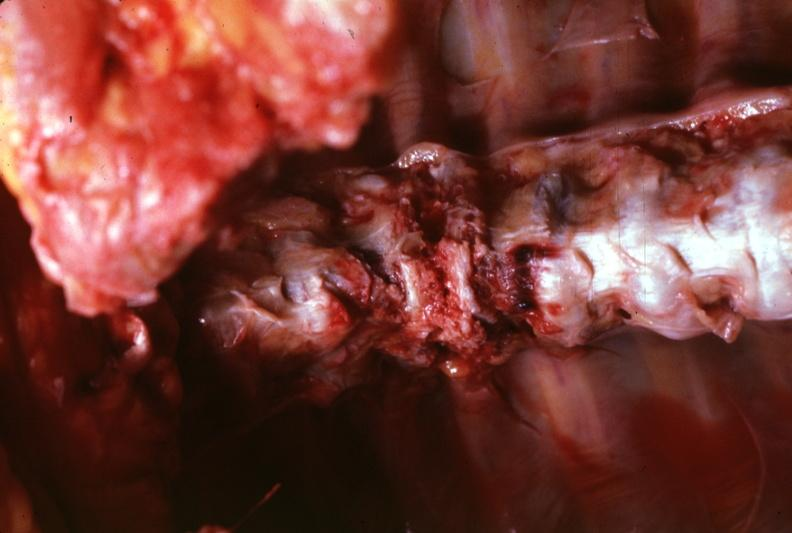does this image show view of spinal column in situ shown rather close-up quite good?
Answer the question using a single word or phrase. Yes 